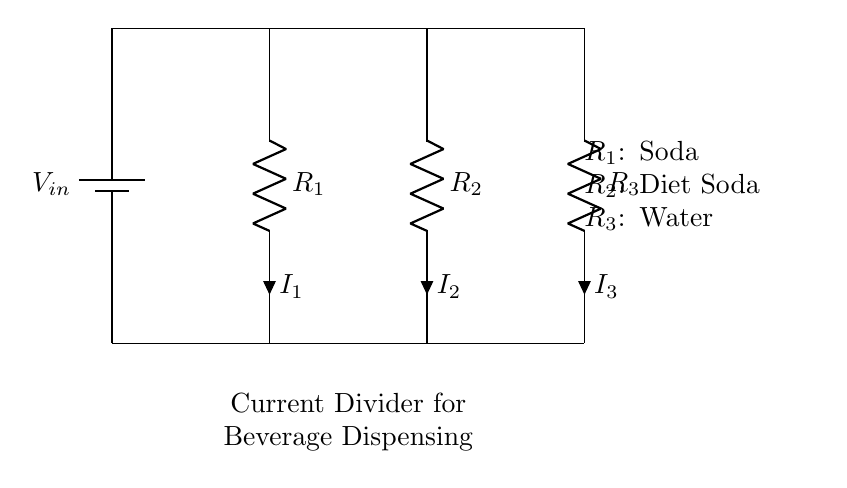What is the voltage input in this circuit? The voltage input in the circuit is indicated as V_in, which represents the source voltage supplied to the entire circuit.
Answer: V_in What are the three resistors labeled as? The labels next to each resistor show their specific contents: R_1 is Soda, R_2 is Diet Soda, and R_3 is Water.
Answer: Soda, Diet Soda, Water What is the current through the resistor R_1? The current flowing through R_1 is denoted as I_1, which is the current that will flow through the Soda dispensing channel in the circuit.
Answer: I_1 Which resistor has the highest current? To determine which resistor has the highest current, one must consider the resistance values; generally, lower resistance will allow more current. Assuming R_1 (Soda) has a lower resistance, I_1 would be the highest.
Answer: I_1 How many branches are there in this current divider circuit? The circuit features three branches created by the three resistors, each representing a path for the current to flow through.
Answer: Three What is the relationship between the currents and resistances in this circuit? In a current divider, the current flowing through each resistor is inversely proportional to its resistance, meaning that as resistance decreases, the current increases for that branch.
Answer: Inverse relationship 